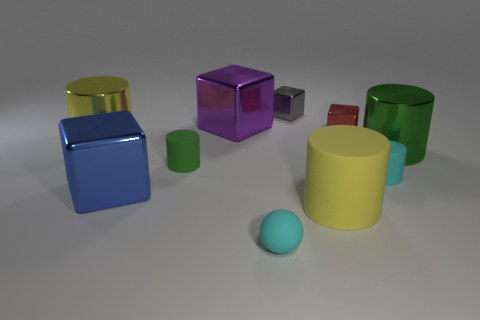Subtract all green matte cylinders. How many cylinders are left? 4 Subtract all brown cubes. How many green cylinders are left? 2 Subtract 1 blocks. How many blocks are left? 3 Subtract all cyan cylinders. How many cylinders are left? 4 Subtract all green cylinders. Subtract all green spheres. How many cylinders are left? 3 Subtract all cubes. How many objects are left? 6 Subtract all big cylinders. Subtract all purple shiny objects. How many objects are left? 6 Add 9 purple metal cubes. How many purple metal cubes are left? 10 Add 8 big metallic cylinders. How many big metallic cylinders exist? 10 Subtract 0 gray spheres. How many objects are left? 10 